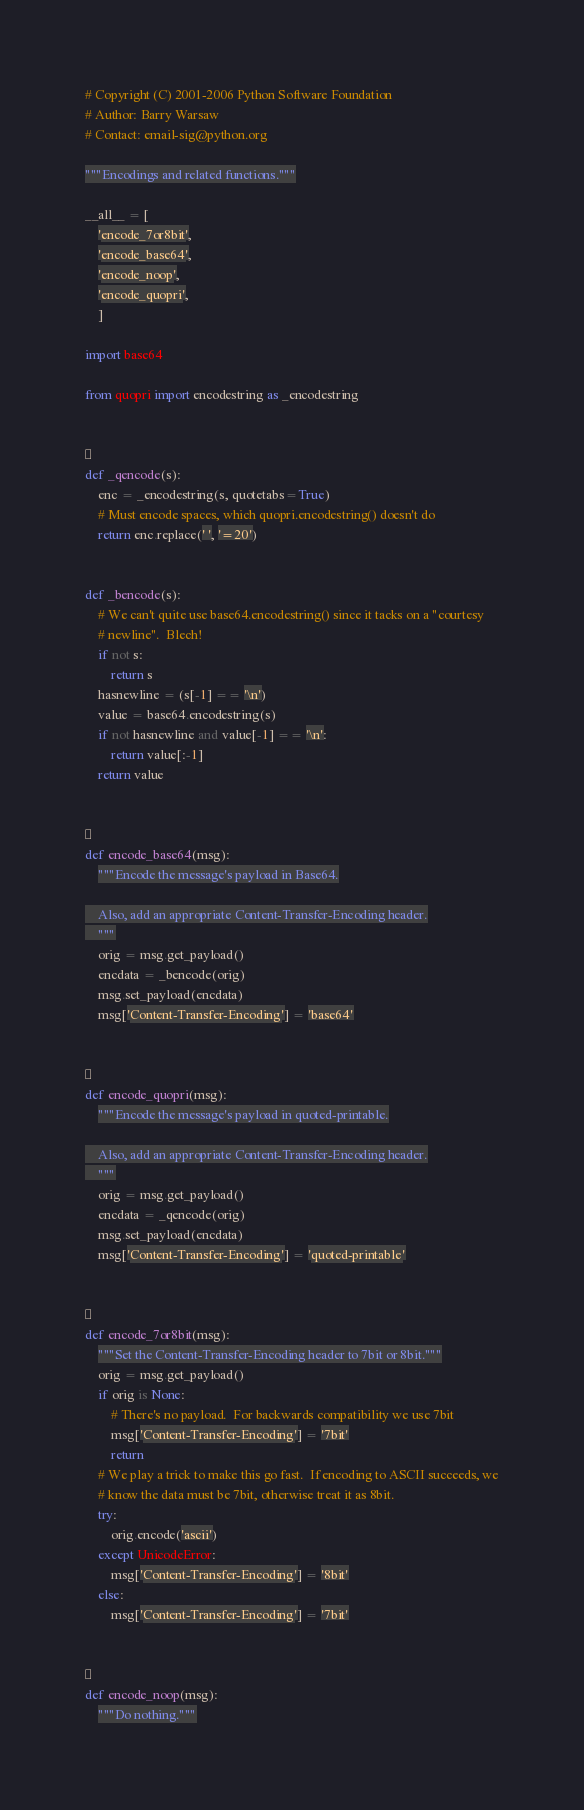<code> <loc_0><loc_0><loc_500><loc_500><_Python_># Copyright (C) 2001-2006 Python Software Foundation
# Author: Barry Warsaw
# Contact: email-sig@python.org

"""Encodings and related functions."""

__all__ = [
    'encode_7or8bit',
    'encode_base64',
    'encode_noop',
    'encode_quopri',
    ]

import base64

from quopri import encodestring as _encodestring



def _qencode(s):
    enc = _encodestring(s, quotetabs=True)
    # Must encode spaces, which quopri.encodestring() doesn't do
    return enc.replace(' ', '=20')


def _bencode(s):
    # We can't quite use base64.encodestring() since it tacks on a "courtesy
    # newline".  Blech!
    if not s:
        return s
    hasnewline = (s[-1] == '\n')
    value = base64.encodestring(s)
    if not hasnewline and value[-1] == '\n':
        return value[:-1]
    return value



def encode_base64(msg):
    """Encode the message's payload in Base64.

    Also, add an appropriate Content-Transfer-Encoding header.
    """
    orig = msg.get_payload()
    encdata = _bencode(orig)
    msg.set_payload(encdata)
    msg['Content-Transfer-Encoding'] = 'base64'



def encode_quopri(msg):
    """Encode the message's payload in quoted-printable.

    Also, add an appropriate Content-Transfer-Encoding header.
    """
    orig = msg.get_payload()
    encdata = _qencode(orig)
    msg.set_payload(encdata)
    msg['Content-Transfer-Encoding'] = 'quoted-printable'



def encode_7or8bit(msg):
    """Set the Content-Transfer-Encoding header to 7bit or 8bit."""
    orig = msg.get_payload()
    if orig is None:
        # There's no payload.  For backwards compatibility we use 7bit
        msg['Content-Transfer-Encoding'] = '7bit'
        return
    # We play a trick to make this go fast.  If encoding to ASCII succeeds, we
    # know the data must be 7bit, otherwise treat it as 8bit.
    try:
        orig.encode('ascii')
    except UnicodeError:
        msg['Content-Transfer-Encoding'] = '8bit'
    else:
        msg['Content-Transfer-Encoding'] = '7bit'



def encode_noop(msg):
    """Do nothing."""
</code> 